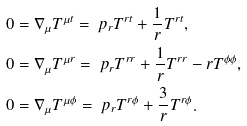Convert formula to latex. <formula><loc_0><loc_0><loc_500><loc_500>0 & = \nabla _ { \mu } T ^ { \mu t } = \ p _ { r } T ^ { r t } + \frac { 1 } { r } T ^ { r t } , \\ 0 & = \nabla _ { \mu } T ^ { \mu r } = \ p _ { r } T ^ { r r } + \frac { 1 } { r } T ^ { r r } - r T ^ { \phi \phi } , \\ 0 & = \nabla _ { \mu } T ^ { \mu \phi } = \ p _ { r } T ^ { r \phi } + \frac { 3 } { r } T ^ { r \phi } .</formula> 